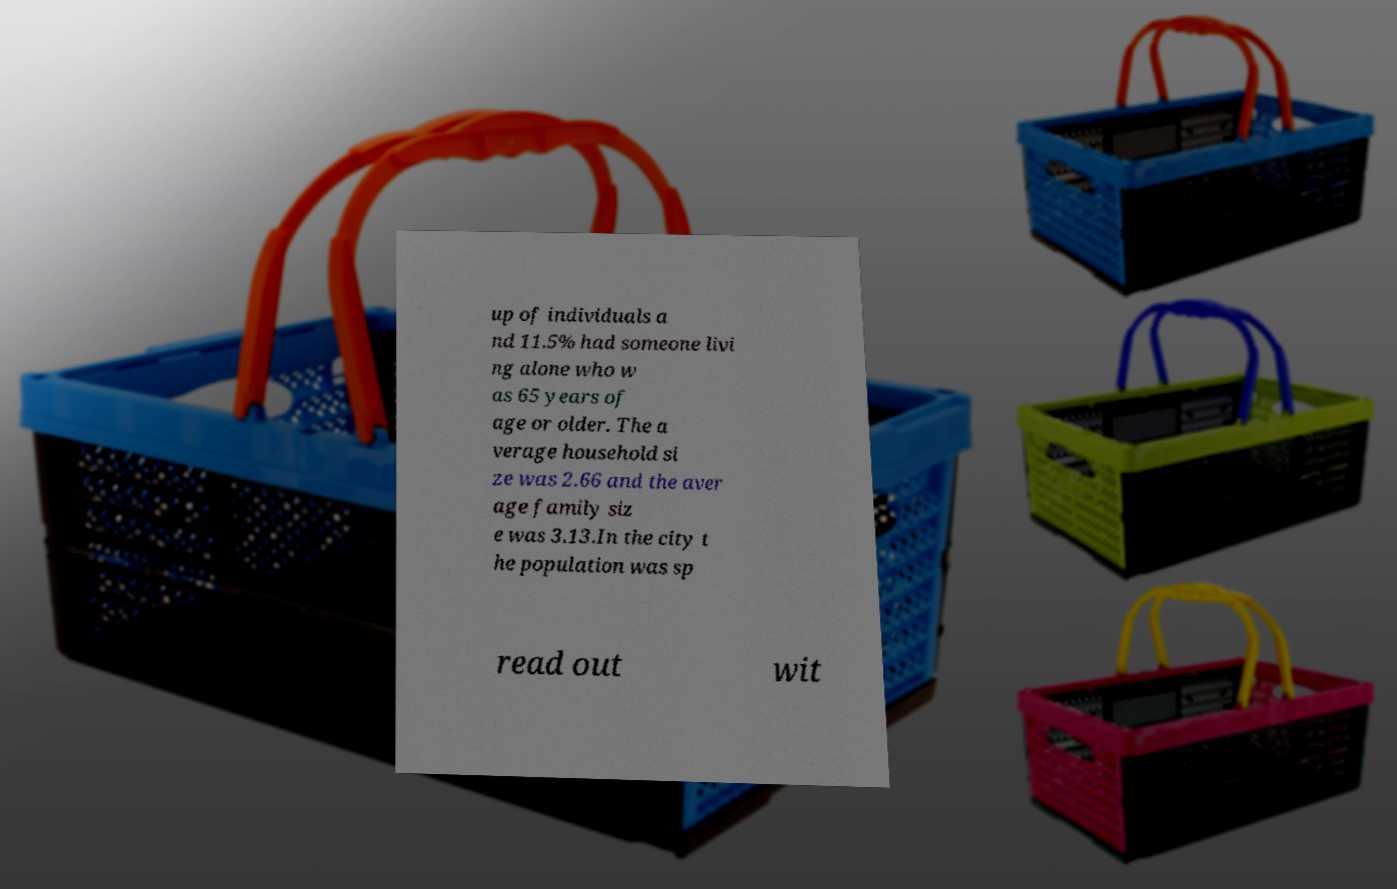Could you assist in decoding the text presented in this image and type it out clearly? up of individuals a nd 11.5% had someone livi ng alone who w as 65 years of age or older. The a verage household si ze was 2.66 and the aver age family siz e was 3.13.In the city t he population was sp read out wit 